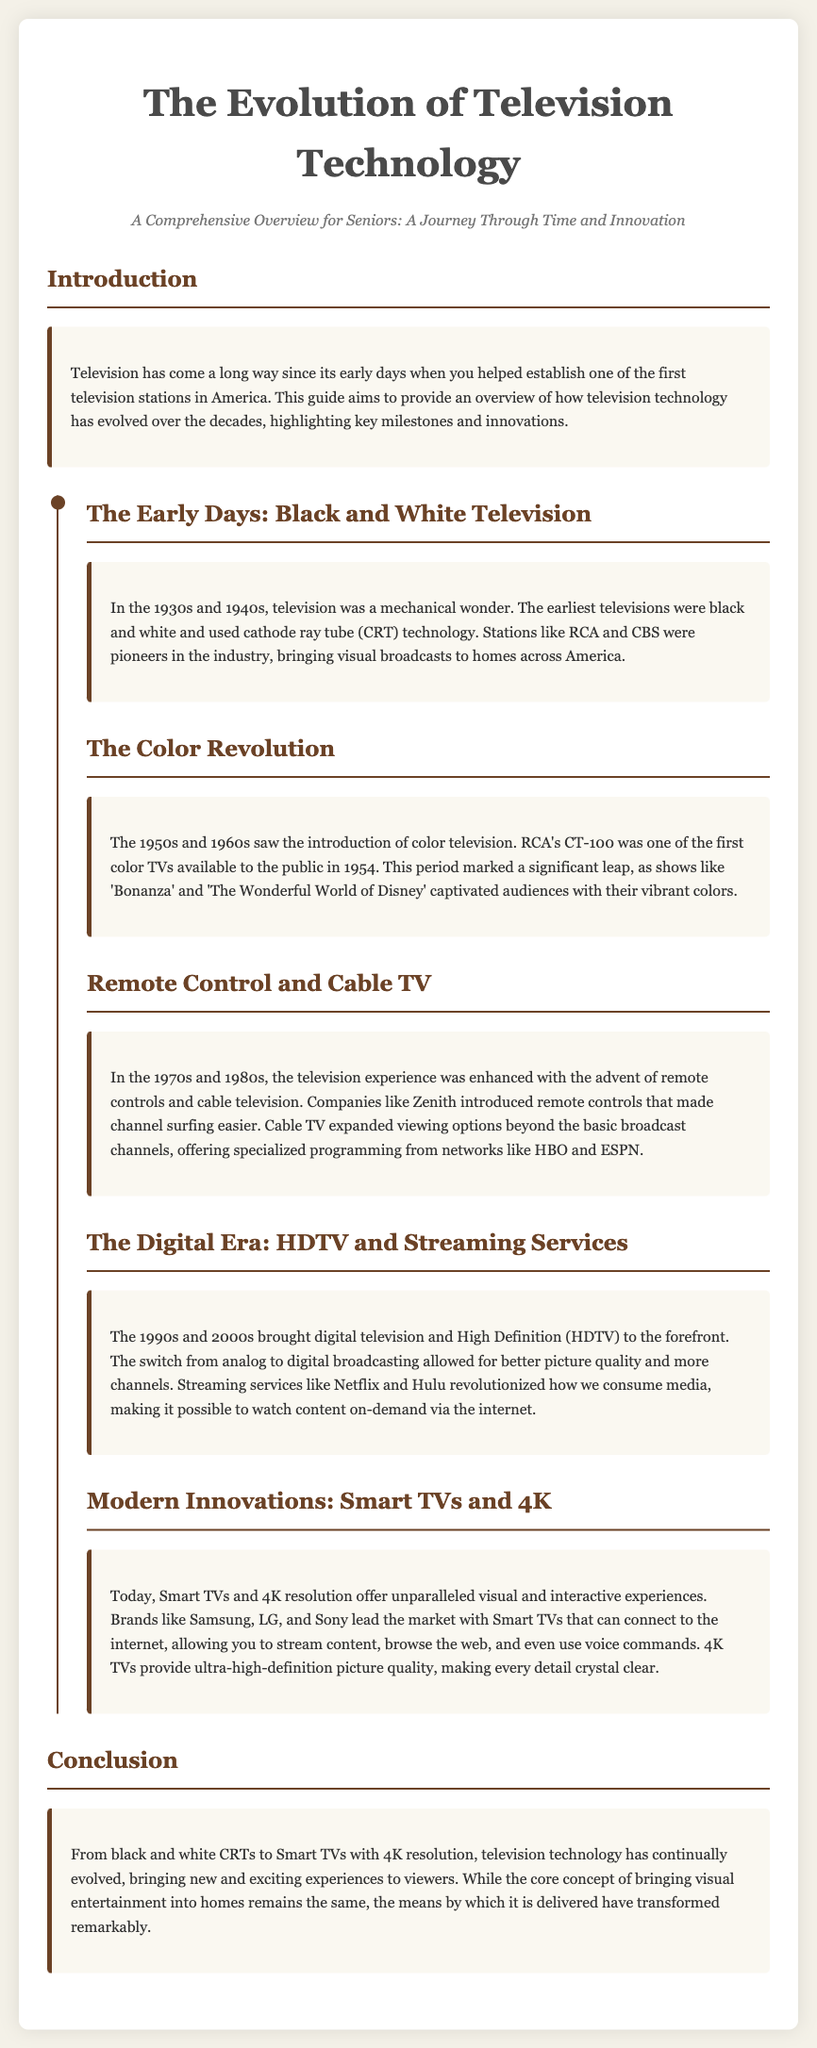What decade saw the introduction of color television? The document states that the 1950s and 1960s marked the introduction of color television.
Answer: 1950s and 1960s Which company's CT-100 was one of the first color TVs? The document mentions RCA's CT-100 as one of the first color TVs available to the public.
Answer: RCA What significant advancement in television technology occurred in the 1990s? The document highlights that the 1990s brought digital television and High Definition (HDTV) to the forefront.
Answer: Digital television and HDTV What was the main purpose of remote controls in the 1970s and 1980s? The document explains that remote controls made channel surfing easier during this period.
Answer: Channel surfing Which brands are mentioned as leaders in the Smart TV market? The document lists Samsung, LG, and Sony as leading brands in the Smart TV market.
Answer: Samsung, LG, Sony What did the switch from analog to digital broadcasting improve? The document states that this switch allowed for better picture quality and more channels.
Answer: Picture quality What kind of programming options did cable TV expand? The document notes that cable television offered specialized programming from networks like HBO and ESPN.
Answer: Specialized programming What is the primary focus of this user guide? The guide aims to provide an overview of how television technology has evolved over the decades.
Answer: Overview of television technology evolution 